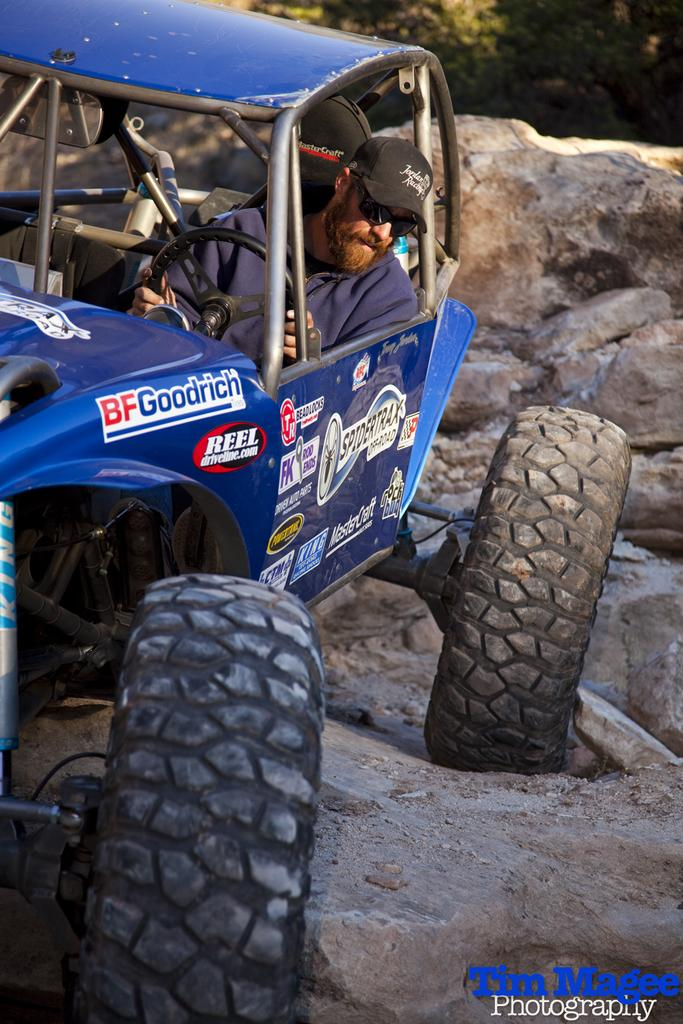What is the person on the motorcycle doing in the image? The person is sitting on a motorcycle and holding a steering. What might the person be wearing to protect their head? The person is wearing a cap in the image. What can be seen in the background of the image? There is a stone and trees visible in the background. How does the person comb their hair while riding the motorcycle in the image? There is no indication in the image that the person is combing their hair, and they are not shown doing so. 